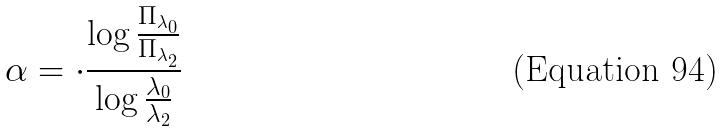Convert formula to latex. <formula><loc_0><loc_0><loc_500><loc_500>\alpha = \cdot \frac { \log \frac { \Pi _ { \lambda _ { 0 } } } { \Pi _ { \lambda _ { 2 } } } } { \log \frac { \lambda _ { 0 } } { \lambda _ { 2 } } }</formula> 